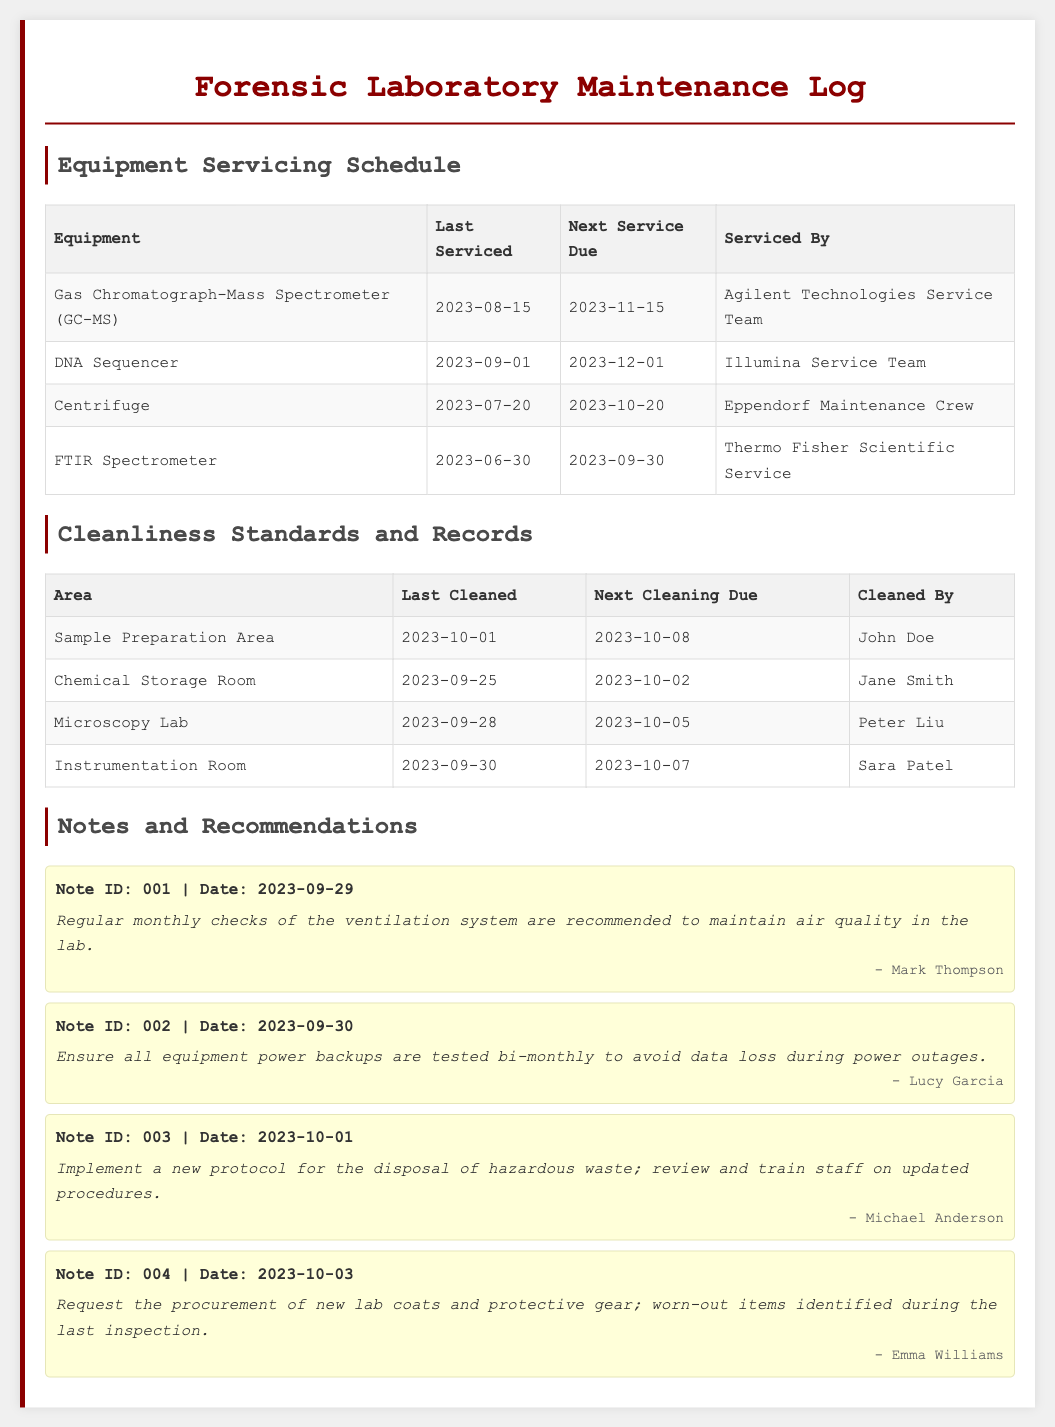What is the next service due for the Gas Chromatograph-Mass Spectrometer? The "Next Service Due" column for the Gas Chromatograph-Mass Spectrometer lists the date 2023-11-15.
Answer: 2023-11-15 Who cleaned the Sample Preparation Area last? The "Cleaned By" column for the Sample Preparation Area indicates that John Doe did the last cleaning.
Answer: John Doe When was the last cleaning of the Chemical Storage Room? The table shows that the last cleaning of the Chemical Storage Room was done on 2023-09-25.
Answer: 2023-09-25 Which equipment was last serviced on 2023-09-01? The "Last Serviced" date of 2023-09-01 corresponds to the DNA Sequencer in the maintenance log.
Answer: DNA Sequencer What is recommended regarding the ventilation system? The note from Mark Thompson suggests regular monthly checks of the ventilation system.
Answer: Monthly checks Who is responsible for the next cleaning of the Microscopy Lab? The "Next Cleaning Due" column for the Microscopy Lab indicates Peter Liu is assigned for next cleaning on 2023-10-05.
Answer: Peter Liu What should be tested bi-monthly according to the recommendations? Lucy Garcia's note specifies that all equipment power backups should be tested bi-monthly.
Answer: Equipment power backups What hazardous waste procedure is mentioned? Michael Anderson's note mentions implementing a new protocol for the disposal of hazardous waste.
Answer: New protocol When is the next service due for the Centrifuge? The "Next Service Due" date for the Centrifuge is listed as 2023-10-20.
Answer: 2023-10-20 What item was requested for procurement in note ID 004? Note ID 004 requests the procurement of new lab coats and protective gear.
Answer: Lab coats and protective gear 